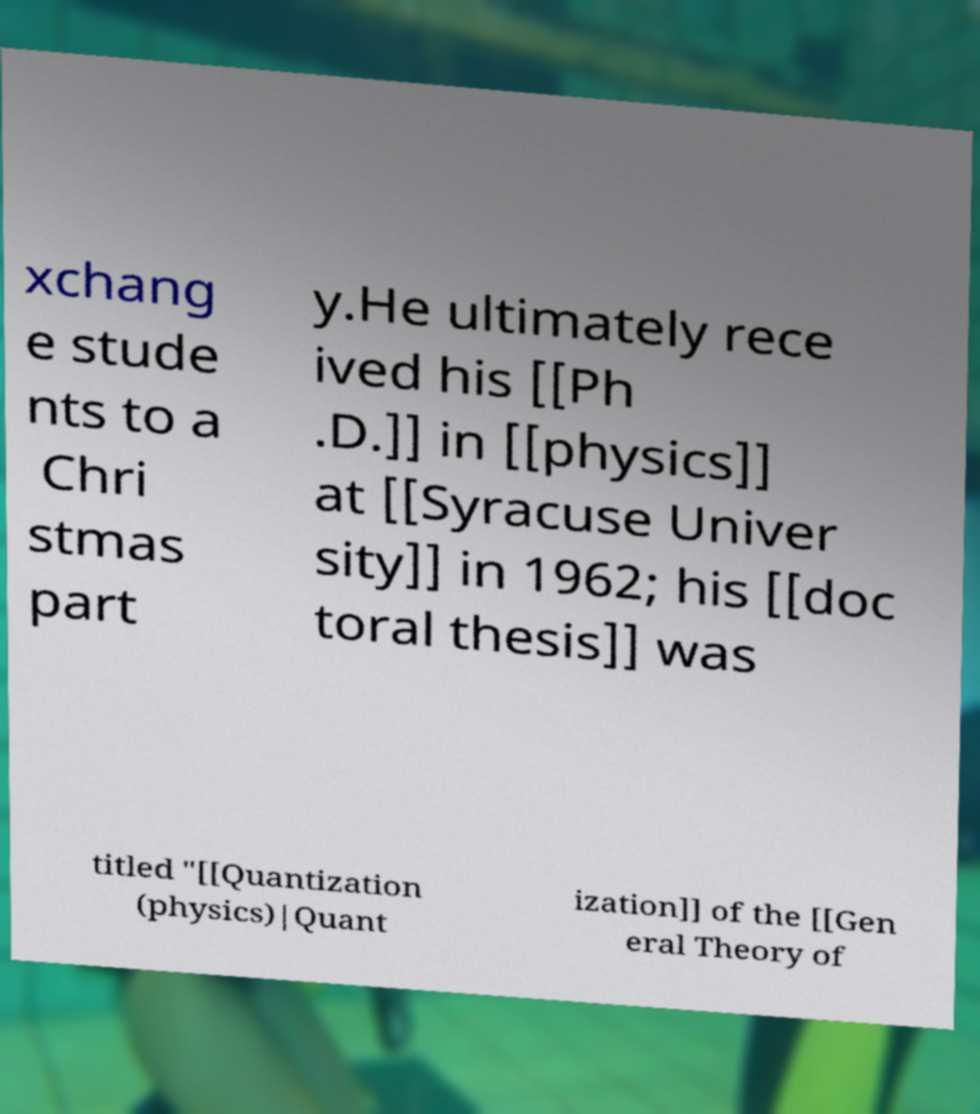Can you accurately transcribe the text from the provided image for me? xchang e stude nts to a Chri stmas part y.He ultimately rece ived his [[Ph .D.]] in [[physics]] at [[Syracuse Univer sity]] in 1962; his [[doc toral thesis]] was titled "[[Quantization (physics)|Quant ization]] of the [[Gen eral Theory of 